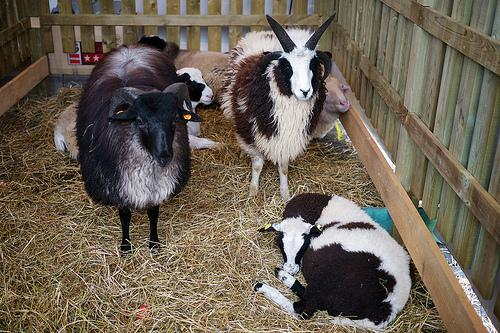List the different tags or markings found on the animals' ears. There is a yellow tag in a sheep's ear, an orange tag on a goat's ear, and an orange tag on a ram's ear. Are there any additional objects aside from the animals in the image? Yes, there is a red white and blue sign with stars, a red object in the straw, and a blue fabric under a calf. Describe the general sentiment of the image. The image has a calm and relaxed sentiment, with animals resting or lying down in a pen filled with hay. What are the two types of horns present in the animals and their positioning? There are tall straight horns and black curved horns; the tall straight horns point up, and the black curved horns are on a goat's head. What color is the hay in the image, and where is it located? The hay is tan and it is located in the stall and under the animals. Give a brief summary of the objects present in the image. There are sheep, goats, hay, wooden pen walls, a wood rail, animal tags, and horns in the image. Identify the type of enclosure that the animals are held in. The animals are held in a pen with wooden slatted walls and a wood rail surrounding it. Can you count the total number of sheep and goats in the image? There are 4 sheep and 3 goats visible in the image. 